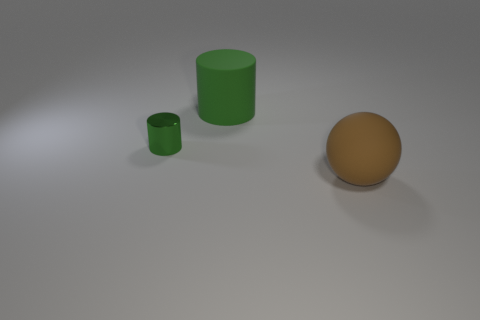What is the shape of the large thing that is the same color as the small shiny object?
Offer a terse response. Cylinder. Are there any large brown rubber balls?
Make the answer very short. Yes. Do the rubber cylinder and the brown rubber object that is in front of the small green metallic thing have the same size?
Your answer should be very brief. Yes. Is there a green cylinder that is in front of the big matte thing that is on the right side of the matte cylinder?
Offer a very short reply. No. What is the thing that is both right of the tiny green object and on the left side of the large brown object made of?
Provide a short and direct response. Rubber. There is a large object that is in front of the green cylinder that is left of the green cylinder behind the green metallic cylinder; what is its color?
Your response must be concise. Brown. What is the color of the thing that is the same size as the green matte cylinder?
Offer a very short reply. Brown. There is a large matte ball; does it have the same color as the cylinder that is on the left side of the rubber cylinder?
Provide a short and direct response. No. What material is the green object to the left of the green object behind the metal thing?
Provide a short and direct response. Metal. How many things are left of the brown rubber object and to the right of the small green metallic thing?
Your answer should be compact. 1. 